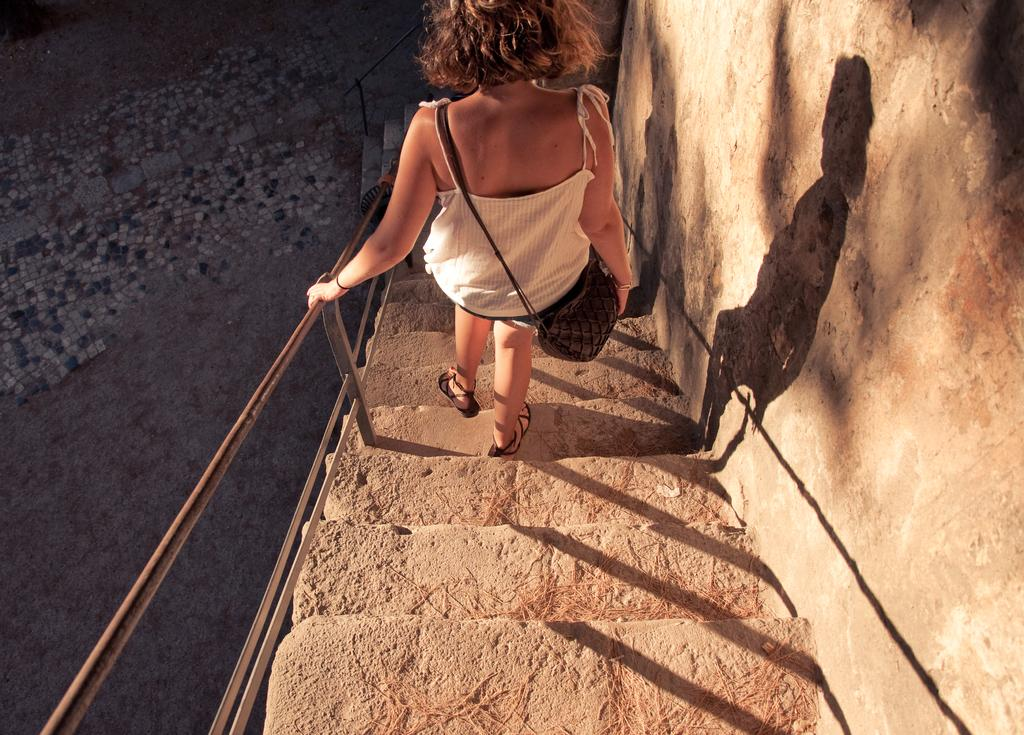Who is present in the image? There is a woman in the image. What is the woman wearing on her feet? The woman is wearing sandals. What is the woman carrying in the image? The woman is carrying a handbag. What is the woman doing in the image? The woman is walking on the steps. What type of structure is present in the image? There are stairs, a fence, a wall, and a footpath in the image. What type of tramp can be seen jumping over the fence in the image? There is no tramp present in the image, and therefore no such activity can be observed. What type of celery is being used to decorate the wall in the image? There is no celery present in the image, and the wall is not decorated with any vegetables. 